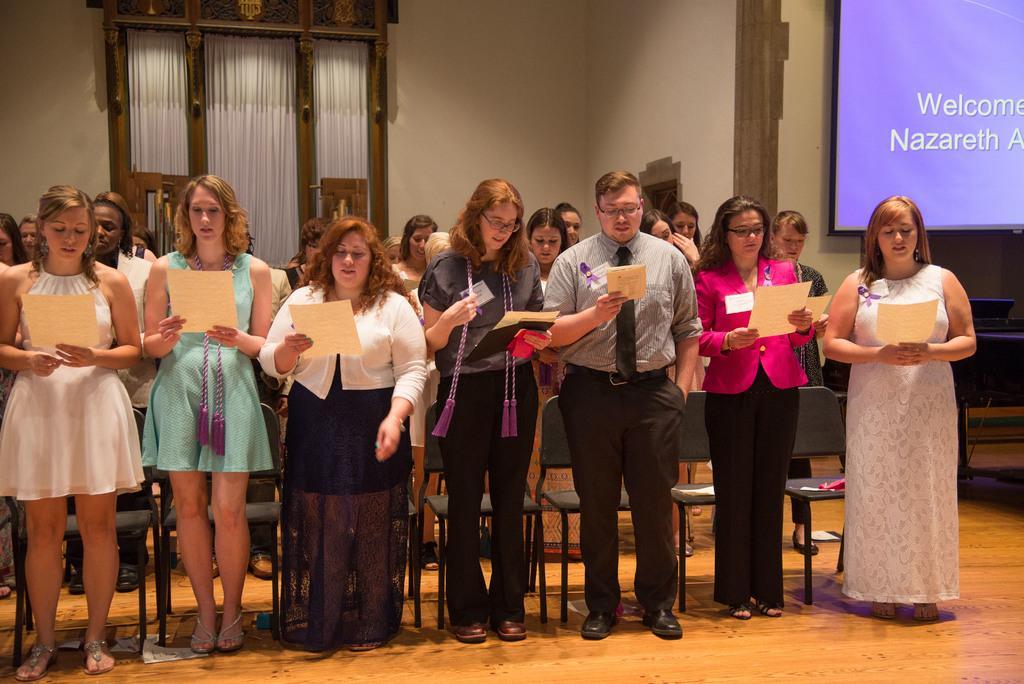How would you summarize this image in a sentence or two? There are few people standing on the floor at the chairs and they are holding papers in their hands. In the background we can see wall,curtains,screen and other objects. 